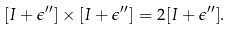<formula> <loc_0><loc_0><loc_500><loc_500>[ I + \epsilon ^ { \prime \prime } ] \times [ I + \epsilon ^ { \prime \prime } ] = 2 [ I + \epsilon ^ { \prime \prime } ] .</formula> 